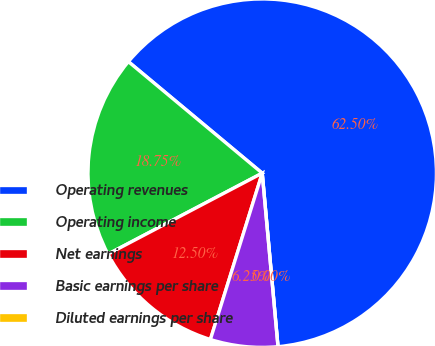<chart> <loc_0><loc_0><loc_500><loc_500><pie_chart><fcel>Operating revenues<fcel>Operating income<fcel>Net earnings<fcel>Basic earnings per share<fcel>Diluted earnings per share<nl><fcel>62.5%<fcel>18.75%<fcel>12.5%<fcel>6.25%<fcel>0.0%<nl></chart> 